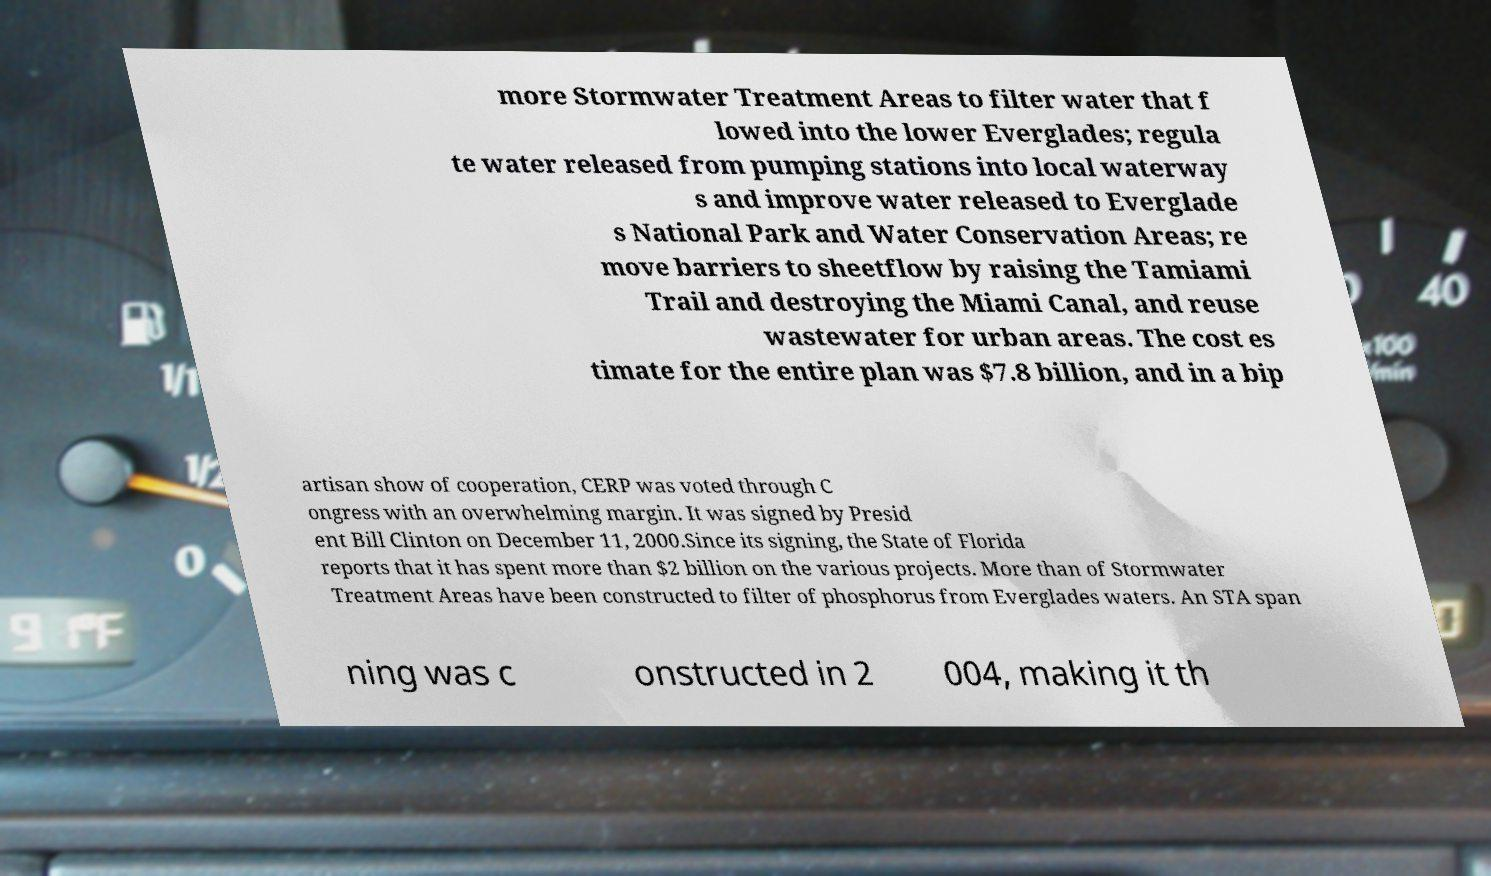There's text embedded in this image that I need extracted. Can you transcribe it verbatim? more Stormwater Treatment Areas to filter water that f lowed into the lower Everglades; regula te water released from pumping stations into local waterway s and improve water released to Everglade s National Park and Water Conservation Areas; re move barriers to sheetflow by raising the Tamiami Trail and destroying the Miami Canal, and reuse wastewater for urban areas. The cost es timate for the entire plan was $7.8 billion, and in a bip artisan show of cooperation, CERP was voted through C ongress with an overwhelming margin. It was signed by Presid ent Bill Clinton on December 11, 2000.Since its signing, the State of Florida reports that it has spent more than $2 billion on the various projects. More than of Stormwater Treatment Areas have been constructed to filter of phosphorus from Everglades waters. An STA span ning was c onstructed in 2 004, making it th 